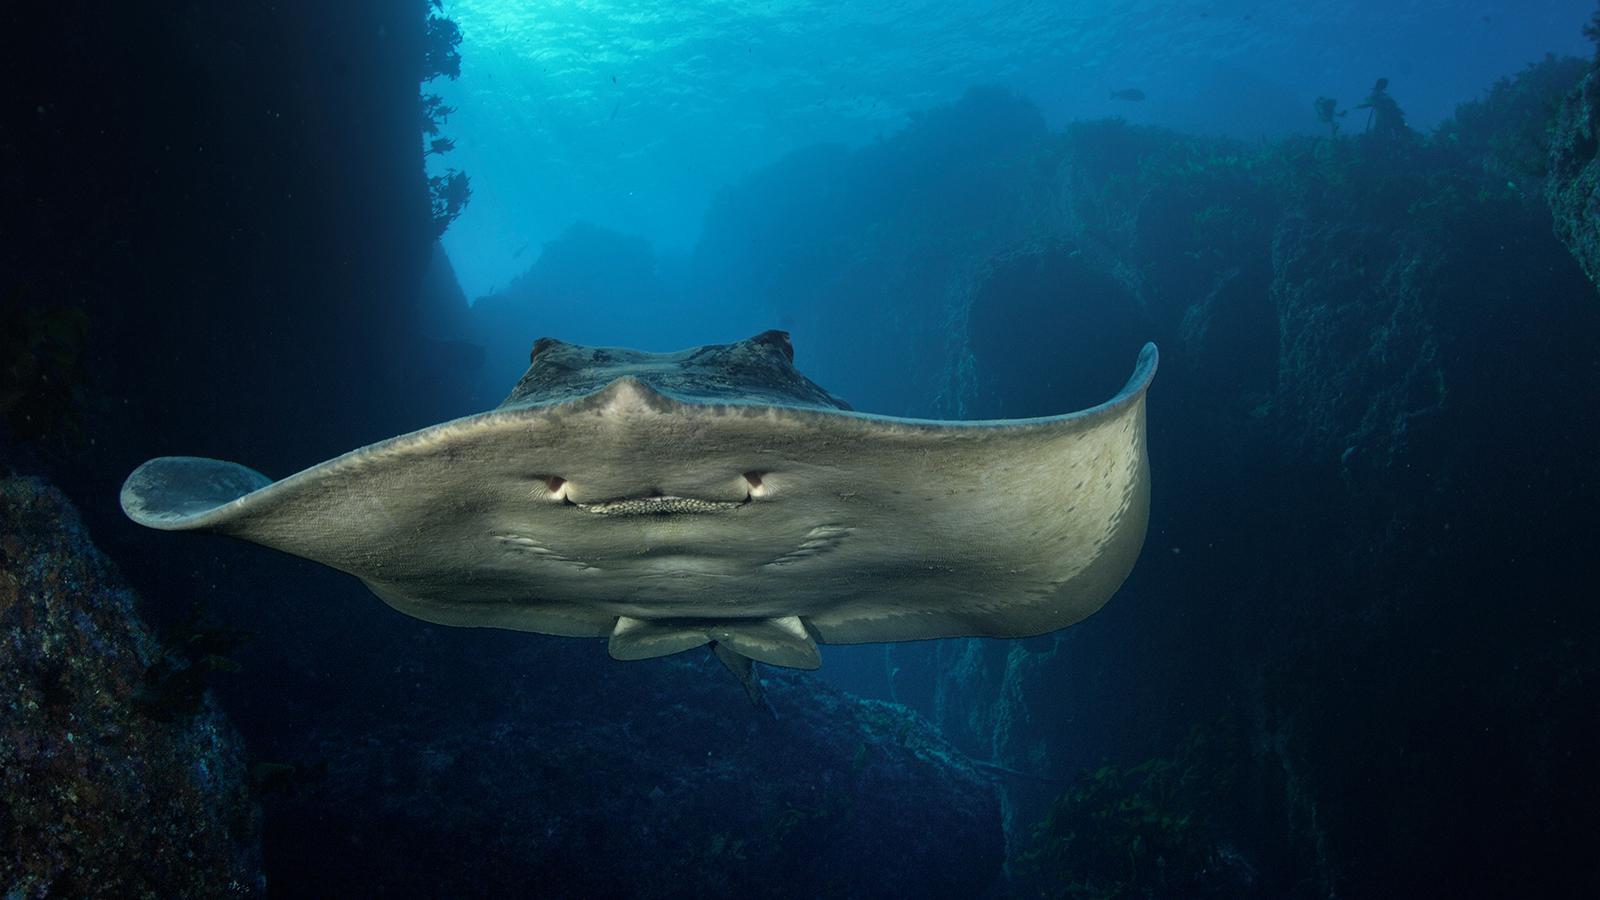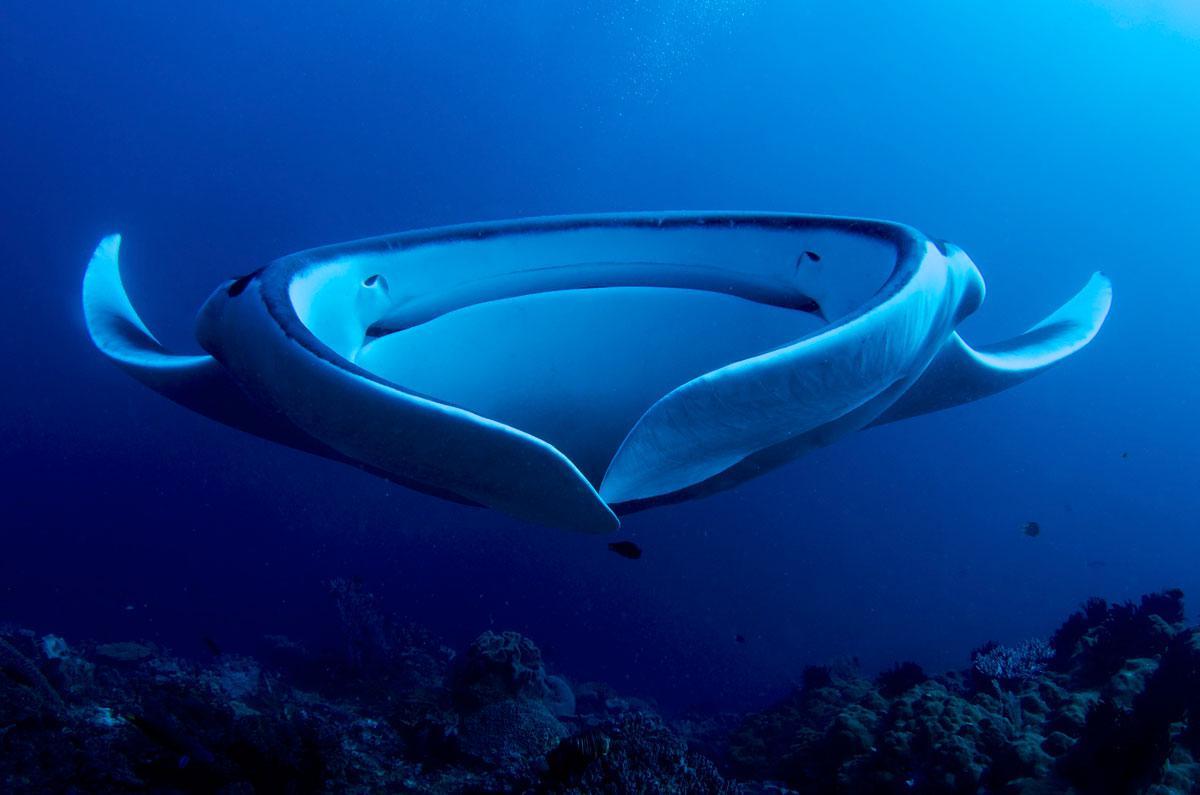The first image is the image on the left, the second image is the image on the right. Considering the images on both sides, is "A total of two stingrays are shown swimming in vivid blue water, with undersides visible." valid? Answer yes or no. Yes. 